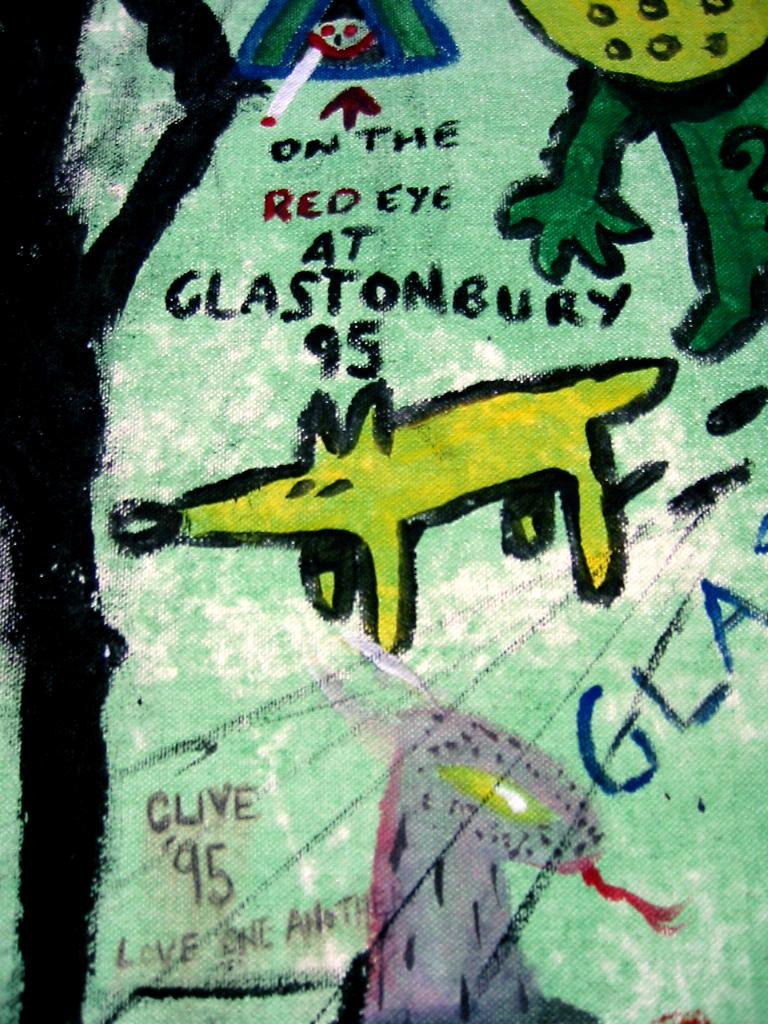<image>
Provide a brief description of the given image. A drawing of a small animal with the text on the red eye at glastonbury 95 on it. 